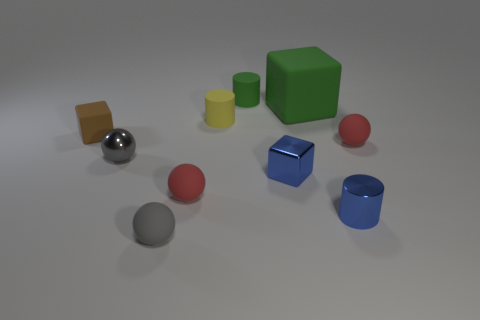How many other things are the same color as the large matte thing?
Your answer should be very brief. 1. There is a small thing that is the same color as the small metallic cube; what is its material?
Provide a succinct answer. Metal. Is there any other thing of the same color as the small matte cube?
Your answer should be very brief. No. There is a tiny gray object that is made of the same material as the blue cube; what is its shape?
Give a very brief answer. Sphere. Do the tiny sphere behind the gray metal object and the blue cylinder have the same material?
Offer a terse response. No. The other matte thing that is the same color as the big thing is what shape?
Keep it short and to the point. Cylinder. Do the matte block that is on the right side of the gray matte ball and the rubber cylinder that is behind the large object have the same color?
Offer a terse response. Yes. What number of tiny blue metallic objects are both to the right of the large green rubber object and behind the blue metallic cylinder?
Your answer should be compact. 0. What material is the big block?
Offer a very short reply. Rubber. The brown thing that is the same size as the gray shiny object is what shape?
Provide a succinct answer. Cube. 